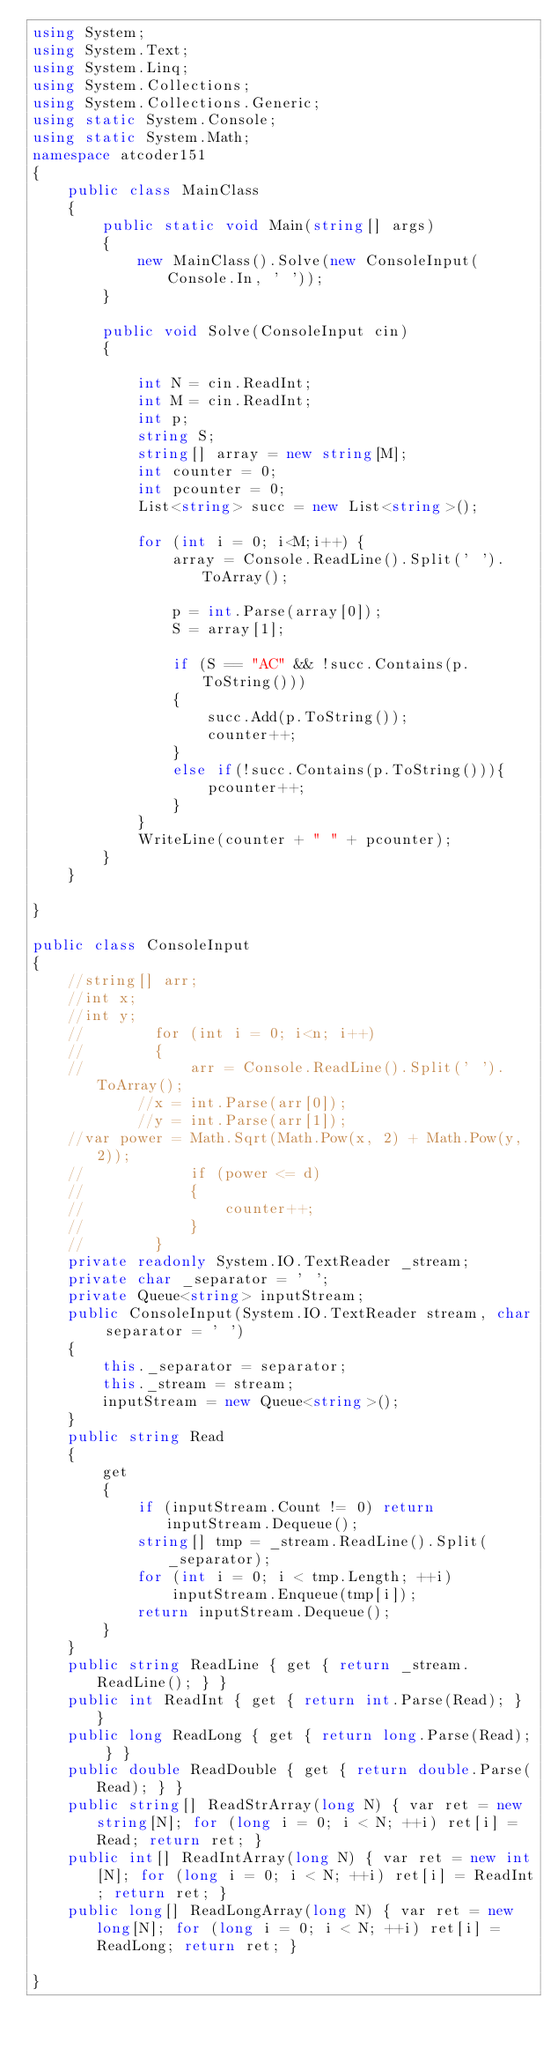Convert code to text. <code><loc_0><loc_0><loc_500><loc_500><_C#_>using System;
using System.Text;
using System.Linq;
using System.Collections;
using System.Collections.Generic;
using static System.Console;
using static System.Math;
namespace atcoder151
{
    public class MainClass
    {
        public static void Main(string[] args)
        {
            new MainClass().Solve(new ConsoleInput(Console.In, ' '));
        }

        public void Solve(ConsoleInput cin)
        {

            int N = cin.ReadInt;
            int M = cin.ReadInt;
            int p;
            string S;
            string[] array = new string[M];
            int counter = 0;
            int pcounter = 0;
            List<string> succ = new List<string>();

            for (int i = 0; i<M;i++) {
                array = Console.ReadLine().Split(' ').ToArray();

                p = int.Parse(array[0]);
                S = array[1];

                if (S == "AC" && !succ.Contains(p.ToString()))
                {
                    succ.Add(p.ToString());
                    counter++;
                }
                else if(!succ.Contains(p.ToString())){
                    pcounter++;
                }                
            }
            WriteLine(counter + " " + pcounter);
        }
    }

}

public class ConsoleInput
{
    //string[] arr;
    //int x;
    //int y;
    //        for (int i = 0; i<n; i++)
    //        {
    //            arr = Console.ReadLine().Split(' ').ToArray();
            //x = int.Parse(arr[0]);
            //y = int.Parse(arr[1]);
    //var power = Math.Sqrt(Math.Pow(x, 2) + Math.Pow(y, 2));
    //            if (power <= d)
    //            {
    //                counter++;
    //            }
    //        }
    private readonly System.IO.TextReader _stream;
    private char _separator = ' ';
    private Queue<string> inputStream;
    public ConsoleInput(System.IO.TextReader stream, char separator = ' ')
    {
        this._separator = separator;
        this._stream = stream;
        inputStream = new Queue<string>();
    }
    public string Read
    {
        get
        {
            if (inputStream.Count != 0) return inputStream.Dequeue();
            string[] tmp = _stream.ReadLine().Split(_separator);
            for (int i = 0; i < tmp.Length; ++i)
                inputStream.Enqueue(tmp[i]);
            return inputStream.Dequeue();
        }
    }
    public string ReadLine { get { return _stream.ReadLine(); } }
    public int ReadInt { get { return int.Parse(Read); } }
    public long ReadLong { get { return long.Parse(Read); } }
    public double ReadDouble { get { return double.Parse(Read); } }
    public string[] ReadStrArray(long N) { var ret = new string[N]; for (long i = 0; i < N; ++i) ret[i] = Read; return ret; }
    public int[] ReadIntArray(long N) { var ret = new int[N]; for (long i = 0; i < N; ++i) ret[i] = ReadInt; return ret; }
    public long[] ReadLongArray(long N) { var ret = new long[N]; for (long i = 0; i < N; ++i) ret[i] = ReadLong; return ret; }

}
</code> 